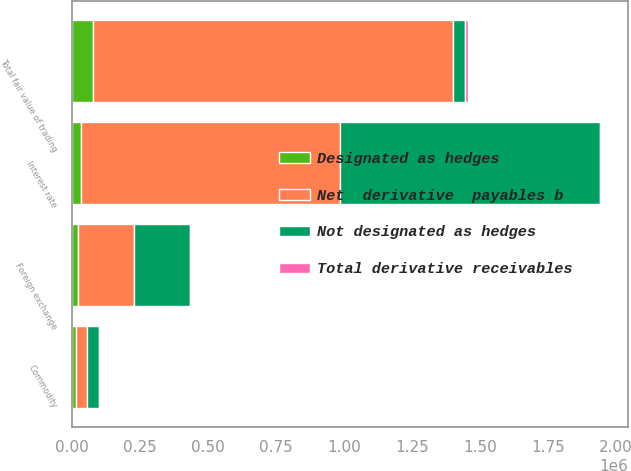Convert chart. <chart><loc_0><loc_0><loc_500><loc_500><stacked_bar_chart><ecel><fcel>Interest rate<fcel>Foreign exchange<fcel>Commodity<fcel>Total fair value of trading<nl><fcel>Net  derivative  payables b<fcel>951151<fcel>205271<fcel>43151<fcel>1.32321e+06<nl><fcel>Total derivative receivables<fcel>5372<fcel>3650<fcel>502<fcel>9524<nl><fcel>Not designated as hedges<fcel>956523<fcel>208921<fcel>43653<fcel>43151<nl><fcel>Designated as hedges<fcel>33725<fcel>21253<fcel>13982<fcel>78975<nl></chart> 